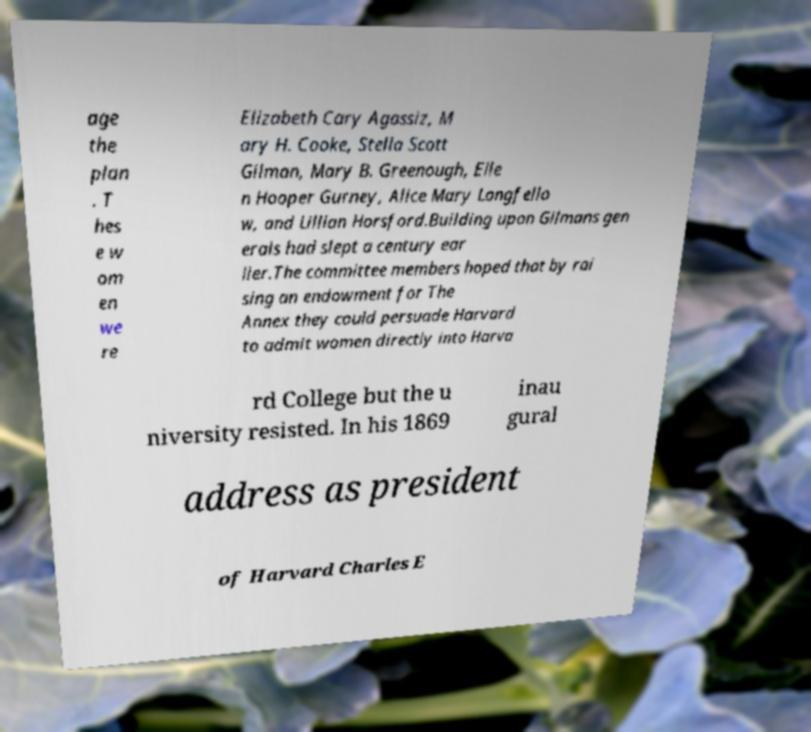I need the written content from this picture converted into text. Can you do that? age the plan . T hes e w om en we re Elizabeth Cary Agassiz, M ary H. Cooke, Stella Scott Gilman, Mary B. Greenough, Elle n Hooper Gurney, Alice Mary Longfello w, and Lillian Horsford.Building upon Gilmans gen erals had slept a century ear lier.The committee members hoped that by rai sing an endowment for The Annex they could persuade Harvard to admit women directly into Harva rd College but the u niversity resisted. In his 1869 inau gural address as president of Harvard Charles E 